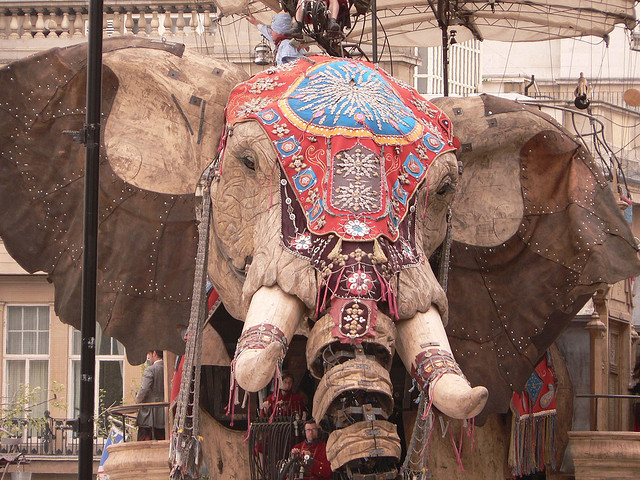<image>What is on the elephants head? I don't know what is on the elephant's head. It could possibly be a decoration, hat, tarp, or cloth. What is on the elephants head? I am not sure what is on the elephants head. It can be seen 'decoration', 'hat', 'tarp', 'decorated cloth', 'headdress' or 'cloth'. 